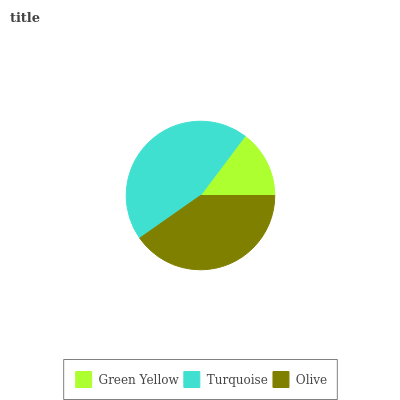Is Green Yellow the minimum?
Answer yes or no. Yes. Is Turquoise the maximum?
Answer yes or no. Yes. Is Olive the minimum?
Answer yes or no. No. Is Olive the maximum?
Answer yes or no. No. Is Turquoise greater than Olive?
Answer yes or no. Yes. Is Olive less than Turquoise?
Answer yes or no. Yes. Is Olive greater than Turquoise?
Answer yes or no. No. Is Turquoise less than Olive?
Answer yes or no. No. Is Olive the high median?
Answer yes or no. Yes. Is Olive the low median?
Answer yes or no. Yes. Is Turquoise the high median?
Answer yes or no. No. Is Turquoise the low median?
Answer yes or no. No. 